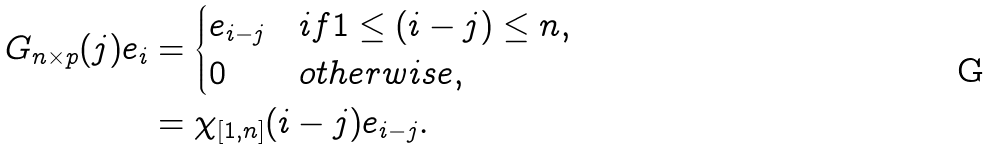<formula> <loc_0><loc_0><loc_500><loc_500>G _ { n \times p } { ( j ) } e _ { i } & = \begin{cases} e _ { i - j } & i f 1 \leq ( i - j ) \leq n , \\ 0 & o t h e r w i s e , \end{cases} \\ & = \chi _ { [ 1 , n ] } ( i - j ) e _ { i - j } .</formula> 